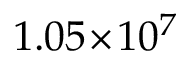Convert formula to latex. <formula><loc_0><loc_0><loc_500><loc_500>1 . 0 5 \, \times \, 1 0 ^ { 7 }</formula> 